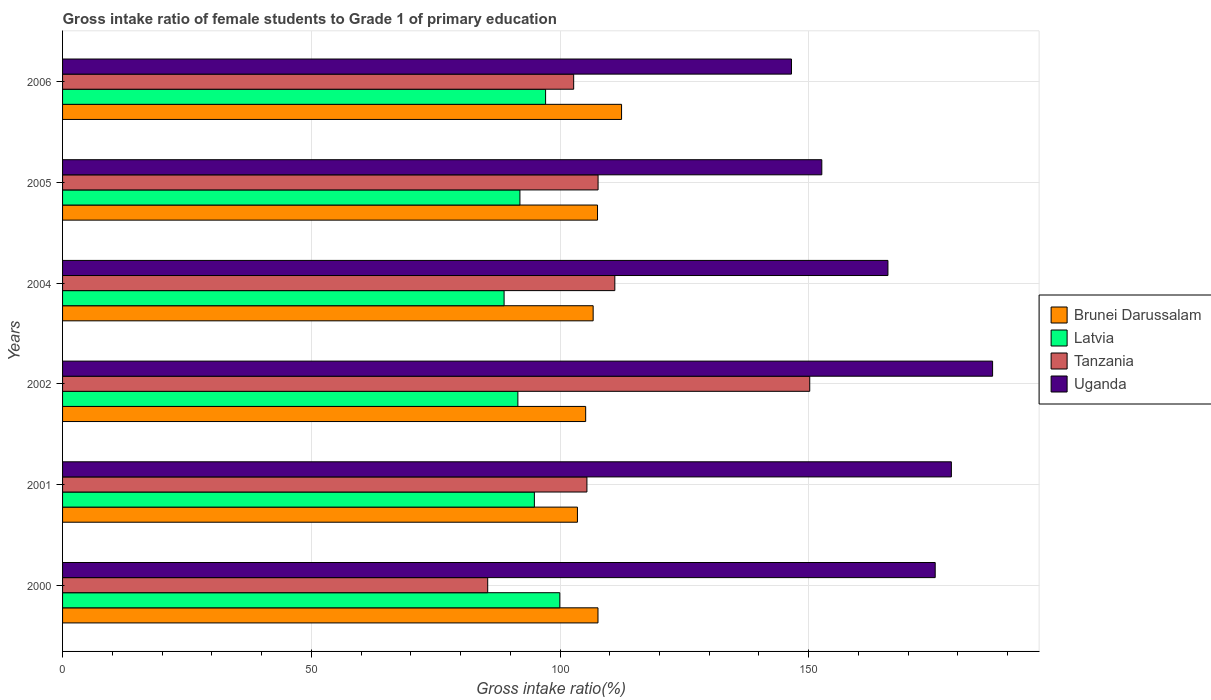How many different coloured bars are there?
Your answer should be compact. 4. Are the number of bars per tick equal to the number of legend labels?
Provide a short and direct response. Yes. Are the number of bars on each tick of the Y-axis equal?
Provide a succinct answer. Yes. How many bars are there on the 2nd tick from the top?
Offer a terse response. 4. How many bars are there on the 2nd tick from the bottom?
Keep it short and to the point. 4. In how many cases, is the number of bars for a given year not equal to the number of legend labels?
Provide a short and direct response. 0. What is the gross intake ratio in Tanzania in 2005?
Offer a very short reply. 107.65. Across all years, what is the maximum gross intake ratio in Tanzania?
Provide a short and direct response. 150.2. Across all years, what is the minimum gross intake ratio in Tanzania?
Provide a succinct answer. 85.47. What is the total gross intake ratio in Brunei Darussalam in the graph?
Your answer should be compact. 642.88. What is the difference between the gross intake ratio in Latvia in 2000 and that in 2006?
Keep it short and to the point. 2.86. What is the difference between the gross intake ratio in Latvia in 2004 and the gross intake ratio in Tanzania in 2000?
Provide a succinct answer. 3.29. What is the average gross intake ratio in Tanzania per year?
Give a very brief answer. 110.42. In the year 2004, what is the difference between the gross intake ratio in Tanzania and gross intake ratio in Latvia?
Offer a terse response. 22.26. In how many years, is the gross intake ratio in Latvia greater than 160 %?
Ensure brevity in your answer.  0. What is the ratio of the gross intake ratio in Uganda in 2000 to that in 2004?
Ensure brevity in your answer.  1.06. What is the difference between the highest and the second highest gross intake ratio in Latvia?
Your answer should be compact. 2.86. What is the difference between the highest and the lowest gross intake ratio in Uganda?
Provide a short and direct response. 40.43. In how many years, is the gross intake ratio in Latvia greater than the average gross intake ratio in Latvia taken over all years?
Provide a succinct answer. 3. Is the sum of the gross intake ratio in Latvia in 2002 and 2005 greater than the maximum gross intake ratio in Uganda across all years?
Offer a terse response. No. Is it the case that in every year, the sum of the gross intake ratio in Uganda and gross intake ratio in Tanzania is greater than the sum of gross intake ratio in Brunei Darussalam and gross intake ratio in Latvia?
Your response must be concise. Yes. What does the 2nd bar from the top in 2000 represents?
Offer a terse response. Tanzania. What does the 3rd bar from the bottom in 2001 represents?
Give a very brief answer. Tanzania. Is it the case that in every year, the sum of the gross intake ratio in Latvia and gross intake ratio in Uganda is greater than the gross intake ratio in Brunei Darussalam?
Your answer should be compact. Yes. Are all the bars in the graph horizontal?
Keep it short and to the point. Yes. How many years are there in the graph?
Your answer should be very brief. 6. How many legend labels are there?
Keep it short and to the point. 4. What is the title of the graph?
Your answer should be very brief. Gross intake ratio of female students to Grade 1 of primary education. Does "Channel Islands" appear as one of the legend labels in the graph?
Offer a very short reply. No. What is the label or title of the X-axis?
Keep it short and to the point. Gross intake ratio(%). What is the Gross intake ratio(%) in Brunei Darussalam in 2000?
Your answer should be compact. 107.64. What is the Gross intake ratio(%) in Latvia in 2000?
Your response must be concise. 99.96. What is the Gross intake ratio(%) in Tanzania in 2000?
Provide a succinct answer. 85.47. What is the Gross intake ratio(%) in Uganda in 2000?
Ensure brevity in your answer.  175.42. What is the Gross intake ratio(%) of Brunei Darussalam in 2001?
Keep it short and to the point. 103.5. What is the Gross intake ratio(%) of Latvia in 2001?
Provide a succinct answer. 94.85. What is the Gross intake ratio(%) in Tanzania in 2001?
Your answer should be very brief. 105.41. What is the Gross intake ratio(%) in Uganda in 2001?
Keep it short and to the point. 178.67. What is the Gross intake ratio(%) in Brunei Darussalam in 2002?
Give a very brief answer. 105.16. What is the Gross intake ratio(%) in Latvia in 2002?
Offer a very short reply. 91.53. What is the Gross intake ratio(%) in Tanzania in 2002?
Keep it short and to the point. 150.2. What is the Gross intake ratio(%) of Uganda in 2002?
Offer a terse response. 186.96. What is the Gross intake ratio(%) in Brunei Darussalam in 2004?
Keep it short and to the point. 106.66. What is the Gross intake ratio(%) of Latvia in 2004?
Offer a terse response. 88.76. What is the Gross intake ratio(%) of Tanzania in 2004?
Make the answer very short. 111.02. What is the Gross intake ratio(%) in Uganda in 2004?
Your response must be concise. 165.92. What is the Gross intake ratio(%) in Brunei Darussalam in 2005?
Your response must be concise. 107.54. What is the Gross intake ratio(%) of Latvia in 2005?
Offer a very short reply. 91.94. What is the Gross intake ratio(%) in Tanzania in 2005?
Your answer should be very brief. 107.65. What is the Gross intake ratio(%) in Uganda in 2005?
Offer a very short reply. 152.63. What is the Gross intake ratio(%) in Brunei Darussalam in 2006?
Give a very brief answer. 112.37. What is the Gross intake ratio(%) of Latvia in 2006?
Give a very brief answer. 97.1. What is the Gross intake ratio(%) of Tanzania in 2006?
Your response must be concise. 102.75. What is the Gross intake ratio(%) of Uganda in 2006?
Your answer should be very brief. 146.53. Across all years, what is the maximum Gross intake ratio(%) of Brunei Darussalam?
Offer a terse response. 112.37. Across all years, what is the maximum Gross intake ratio(%) of Latvia?
Provide a short and direct response. 99.96. Across all years, what is the maximum Gross intake ratio(%) of Tanzania?
Provide a short and direct response. 150.2. Across all years, what is the maximum Gross intake ratio(%) of Uganda?
Your response must be concise. 186.96. Across all years, what is the minimum Gross intake ratio(%) of Brunei Darussalam?
Make the answer very short. 103.5. Across all years, what is the minimum Gross intake ratio(%) in Latvia?
Keep it short and to the point. 88.76. Across all years, what is the minimum Gross intake ratio(%) of Tanzania?
Provide a succinct answer. 85.47. Across all years, what is the minimum Gross intake ratio(%) in Uganda?
Make the answer very short. 146.53. What is the total Gross intake ratio(%) in Brunei Darussalam in the graph?
Ensure brevity in your answer.  642.88. What is the total Gross intake ratio(%) in Latvia in the graph?
Your response must be concise. 564.14. What is the total Gross intake ratio(%) of Tanzania in the graph?
Offer a very short reply. 662.5. What is the total Gross intake ratio(%) of Uganda in the graph?
Provide a succinct answer. 1006.15. What is the difference between the Gross intake ratio(%) in Brunei Darussalam in 2000 and that in 2001?
Offer a terse response. 4.13. What is the difference between the Gross intake ratio(%) in Latvia in 2000 and that in 2001?
Give a very brief answer. 5.11. What is the difference between the Gross intake ratio(%) in Tanzania in 2000 and that in 2001?
Give a very brief answer. -19.95. What is the difference between the Gross intake ratio(%) in Uganda in 2000 and that in 2001?
Your answer should be very brief. -3.25. What is the difference between the Gross intake ratio(%) in Brunei Darussalam in 2000 and that in 2002?
Your answer should be compact. 2.48. What is the difference between the Gross intake ratio(%) in Latvia in 2000 and that in 2002?
Your answer should be compact. 8.43. What is the difference between the Gross intake ratio(%) of Tanzania in 2000 and that in 2002?
Provide a succinct answer. -64.74. What is the difference between the Gross intake ratio(%) of Uganda in 2000 and that in 2002?
Make the answer very short. -11.54. What is the difference between the Gross intake ratio(%) in Brunei Darussalam in 2000 and that in 2004?
Provide a short and direct response. 0.97. What is the difference between the Gross intake ratio(%) of Latvia in 2000 and that in 2004?
Offer a very short reply. 11.2. What is the difference between the Gross intake ratio(%) of Tanzania in 2000 and that in 2004?
Ensure brevity in your answer.  -25.55. What is the difference between the Gross intake ratio(%) of Uganda in 2000 and that in 2004?
Provide a succinct answer. 9.5. What is the difference between the Gross intake ratio(%) of Brunei Darussalam in 2000 and that in 2005?
Keep it short and to the point. 0.09. What is the difference between the Gross intake ratio(%) in Latvia in 2000 and that in 2005?
Give a very brief answer. 8.02. What is the difference between the Gross intake ratio(%) of Tanzania in 2000 and that in 2005?
Your response must be concise. -22.19. What is the difference between the Gross intake ratio(%) of Uganda in 2000 and that in 2005?
Ensure brevity in your answer.  22.8. What is the difference between the Gross intake ratio(%) in Brunei Darussalam in 2000 and that in 2006?
Give a very brief answer. -4.74. What is the difference between the Gross intake ratio(%) in Latvia in 2000 and that in 2006?
Keep it short and to the point. 2.86. What is the difference between the Gross intake ratio(%) of Tanzania in 2000 and that in 2006?
Ensure brevity in your answer.  -17.28. What is the difference between the Gross intake ratio(%) of Uganda in 2000 and that in 2006?
Provide a succinct answer. 28.89. What is the difference between the Gross intake ratio(%) of Brunei Darussalam in 2001 and that in 2002?
Ensure brevity in your answer.  -1.65. What is the difference between the Gross intake ratio(%) in Latvia in 2001 and that in 2002?
Your answer should be very brief. 3.32. What is the difference between the Gross intake ratio(%) of Tanzania in 2001 and that in 2002?
Your answer should be compact. -44.79. What is the difference between the Gross intake ratio(%) in Uganda in 2001 and that in 2002?
Make the answer very short. -8.29. What is the difference between the Gross intake ratio(%) of Brunei Darussalam in 2001 and that in 2004?
Offer a very short reply. -3.16. What is the difference between the Gross intake ratio(%) in Latvia in 2001 and that in 2004?
Offer a terse response. 6.09. What is the difference between the Gross intake ratio(%) of Tanzania in 2001 and that in 2004?
Keep it short and to the point. -5.61. What is the difference between the Gross intake ratio(%) of Uganda in 2001 and that in 2004?
Provide a succinct answer. 12.75. What is the difference between the Gross intake ratio(%) in Brunei Darussalam in 2001 and that in 2005?
Offer a terse response. -4.04. What is the difference between the Gross intake ratio(%) of Latvia in 2001 and that in 2005?
Your response must be concise. 2.9. What is the difference between the Gross intake ratio(%) of Tanzania in 2001 and that in 2005?
Keep it short and to the point. -2.24. What is the difference between the Gross intake ratio(%) in Uganda in 2001 and that in 2005?
Your answer should be compact. 26.05. What is the difference between the Gross intake ratio(%) of Brunei Darussalam in 2001 and that in 2006?
Keep it short and to the point. -8.87. What is the difference between the Gross intake ratio(%) of Latvia in 2001 and that in 2006?
Ensure brevity in your answer.  -2.26. What is the difference between the Gross intake ratio(%) in Tanzania in 2001 and that in 2006?
Provide a succinct answer. 2.66. What is the difference between the Gross intake ratio(%) of Uganda in 2001 and that in 2006?
Offer a very short reply. 32.14. What is the difference between the Gross intake ratio(%) in Brunei Darussalam in 2002 and that in 2004?
Your response must be concise. -1.51. What is the difference between the Gross intake ratio(%) of Latvia in 2002 and that in 2004?
Your answer should be compact. 2.77. What is the difference between the Gross intake ratio(%) in Tanzania in 2002 and that in 2004?
Keep it short and to the point. 39.18. What is the difference between the Gross intake ratio(%) in Uganda in 2002 and that in 2004?
Give a very brief answer. 21.04. What is the difference between the Gross intake ratio(%) in Brunei Darussalam in 2002 and that in 2005?
Provide a succinct answer. -2.38. What is the difference between the Gross intake ratio(%) in Latvia in 2002 and that in 2005?
Give a very brief answer. -0.41. What is the difference between the Gross intake ratio(%) in Tanzania in 2002 and that in 2005?
Give a very brief answer. 42.55. What is the difference between the Gross intake ratio(%) of Uganda in 2002 and that in 2005?
Ensure brevity in your answer.  34.33. What is the difference between the Gross intake ratio(%) in Brunei Darussalam in 2002 and that in 2006?
Your response must be concise. -7.21. What is the difference between the Gross intake ratio(%) in Latvia in 2002 and that in 2006?
Offer a very short reply. -5.57. What is the difference between the Gross intake ratio(%) in Tanzania in 2002 and that in 2006?
Provide a succinct answer. 47.45. What is the difference between the Gross intake ratio(%) in Uganda in 2002 and that in 2006?
Give a very brief answer. 40.43. What is the difference between the Gross intake ratio(%) in Brunei Darussalam in 2004 and that in 2005?
Provide a succinct answer. -0.88. What is the difference between the Gross intake ratio(%) in Latvia in 2004 and that in 2005?
Your answer should be compact. -3.18. What is the difference between the Gross intake ratio(%) of Tanzania in 2004 and that in 2005?
Ensure brevity in your answer.  3.37. What is the difference between the Gross intake ratio(%) of Uganda in 2004 and that in 2005?
Your response must be concise. 13.29. What is the difference between the Gross intake ratio(%) of Brunei Darussalam in 2004 and that in 2006?
Provide a succinct answer. -5.71. What is the difference between the Gross intake ratio(%) of Latvia in 2004 and that in 2006?
Provide a succinct answer. -8.34. What is the difference between the Gross intake ratio(%) in Tanzania in 2004 and that in 2006?
Provide a succinct answer. 8.27. What is the difference between the Gross intake ratio(%) of Uganda in 2004 and that in 2006?
Offer a very short reply. 19.39. What is the difference between the Gross intake ratio(%) of Brunei Darussalam in 2005 and that in 2006?
Offer a very short reply. -4.83. What is the difference between the Gross intake ratio(%) of Latvia in 2005 and that in 2006?
Provide a succinct answer. -5.16. What is the difference between the Gross intake ratio(%) in Tanzania in 2005 and that in 2006?
Your answer should be very brief. 4.91. What is the difference between the Gross intake ratio(%) in Uganda in 2005 and that in 2006?
Ensure brevity in your answer.  6.09. What is the difference between the Gross intake ratio(%) of Brunei Darussalam in 2000 and the Gross intake ratio(%) of Latvia in 2001?
Offer a very short reply. 12.79. What is the difference between the Gross intake ratio(%) in Brunei Darussalam in 2000 and the Gross intake ratio(%) in Tanzania in 2001?
Make the answer very short. 2.22. What is the difference between the Gross intake ratio(%) in Brunei Darussalam in 2000 and the Gross intake ratio(%) in Uganda in 2001?
Keep it short and to the point. -71.04. What is the difference between the Gross intake ratio(%) of Latvia in 2000 and the Gross intake ratio(%) of Tanzania in 2001?
Make the answer very short. -5.45. What is the difference between the Gross intake ratio(%) of Latvia in 2000 and the Gross intake ratio(%) of Uganda in 2001?
Provide a short and direct response. -78.71. What is the difference between the Gross intake ratio(%) of Tanzania in 2000 and the Gross intake ratio(%) of Uganda in 2001?
Offer a very short reply. -93.21. What is the difference between the Gross intake ratio(%) of Brunei Darussalam in 2000 and the Gross intake ratio(%) of Latvia in 2002?
Provide a succinct answer. 16.1. What is the difference between the Gross intake ratio(%) in Brunei Darussalam in 2000 and the Gross intake ratio(%) in Tanzania in 2002?
Your answer should be compact. -42.57. What is the difference between the Gross intake ratio(%) in Brunei Darussalam in 2000 and the Gross intake ratio(%) in Uganda in 2002?
Give a very brief answer. -79.33. What is the difference between the Gross intake ratio(%) in Latvia in 2000 and the Gross intake ratio(%) in Tanzania in 2002?
Give a very brief answer. -50.24. What is the difference between the Gross intake ratio(%) of Latvia in 2000 and the Gross intake ratio(%) of Uganda in 2002?
Keep it short and to the point. -87. What is the difference between the Gross intake ratio(%) in Tanzania in 2000 and the Gross intake ratio(%) in Uganda in 2002?
Ensure brevity in your answer.  -101.5. What is the difference between the Gross intake ratio(%) of Brunei Darussalam in 2000 and the Gross intake ratio(%) of Latvia in 2004?
Make the answer very short. 18.88. What is the difference between the Gross intake ratio(%) in Brunei Darussalam in 2000 and the Gross intake ratio(%) in Tanzania in 2004?
Your response must be concise. -3.38. What is the difference between the Gross intake ratio(%) in Brunei Darussalam in 2000 and the Gross intake ratio(%) in Uganda in 2004?
Make the answer very short. -58.29. What is the difference between the Gross intake ratio(%) of Latvia in 2000 and the Gross intake ratio(%) of Tanzania in 2004?
Make the answer very short. -11.06. What is the difference between the Gross intake ratio(%) of Latvia in 2000 and the Gross intake ratio(%) of Uganda in 2004?
Offer a very short reply. -65.96. What is the difference between the Gross intake ratio(%) in Tanzania in 2000 and the Gross intake ratio(%) in Uganda in 2004?
Provide a succinct answer. -80.46. What is the difference between the Gross intake ratio(%) in Brunei Darussalam in 2000 and the Gross intake ratio(%) in Latvia in 2005?
Keep it short and to the point. 15.69. What is the difference between the Gross intake ratio(%) of Brunei Darussalam in 2000 and the Gross intake ratio(%) of Tanzania in 2005?
Ensure brevity in your answer.  -0.02. What is the difference between the Gross intake ratio(%) of Brunei Darussalam in 2000 and the Gross intake ratio(%) of Uganda in 2005?
Your answer should be compact. -44.99. What is the difference between the Gross intake ratio(%) of Latvia in 2000 and the Gross intake ratio(%) of Tanzania in 2005?
Offer a very short reply. -7.69. What is the difference between the Gross intake ratio(%) of Latvia in 2000 and the Gross intake ratio(%) of Uganda in 2005?
Keep it short and to the point. -52.67. What is the difference between the Gross intake ratio(%) in Tanzania in 2000 and the Gross intake ratio(%) in Uganda in 2005?
Provide a short and direct response. -67.16. What is the difference between the Gross intake ratio(%) of Brunei Darussalam in 2000 and the Gross intake ratio(%) of Latvia in 2006?
Your answer should be compact. 10.53. What is the difference between the Gross intake ratio(%) of Brunei Darussalam in 2000 and the Gross intake ratio(%) of Tanzania in 2006?
Make the answer very short. 4.89. What is the difference between the Gross intake ratio(%) in Brunei Darussalam in 2000 and the Gross intake ratio(%) in Uganda in 2006?
Offer a very short reply. -38.9. What is the difference between the Gross intake ratio(%) in Latvia in 2000 and the Gross intake ratio(%) in Tanzania in 2006?
Ensure brevity in your answer.  -2.79. What is the difference between the Gross intake ratio(%) of Latvia in 2000 and the Gross intake ratio(%) of Uganda in 2006?
Provide a succinct answer. -46.57. What is the difference between the Gross intake ratio(%) in Tanzania in 2000 and the Gross intake ratio(%) in Uganda in 2006?
Keep it short and to the point. -61.07. What is the difference between the Gross intake ratio(%) in Brunei Darussalam in 2001 and the Gross intake ratio(%) in Latvia in 2002?
Offer a very short reply. 11.97. What is the difference between the Gross intake ratio(%) in Brunei Darussalam in 2001 and the Gross intake ratio(%) in Tanzania in 2002?
Offer a very short reply. -46.7. What is the difference between the Gross intake ratio(%) of Brunei Darussalam in 2001 and the Gross intake ratio(%) of Uganda in 2002?
Offer a terse response. -83.46. What is the difference between the Gross intake ratio(%) in Latvia in 2001 and the Gross intake ratio(%) in Tanzania in 2002?
Give a very brief answer. -55.36. What is the difference between the Gross intake ratio(%) of Latvia in 2001 and the Gross intake ratio(%) of Uganda in 2002?
Offer a terse response. -92.12. What is the difference between the Gross intake ratio(%) in Tanzania in 2001 and the Gross intake ratio(%) in Uganda in 2002?
Make the answer very short. -81.55. What is the difference between the Gross intake ratio(%) in Brunei Darussalam in 2001 and the Gross intake ratio(%) in Latvia in 2004?
Your answer should be compact. 14.74. What is the difference between the Gross intake ratio(%) in Brunei Darussalam in 2001 and the Gross intake ratio(%) in Tanzania in 2004?
Your answer should be very brief. -7.52. What is the difference between the Gross intake ratio(%) of Brunei Darussalam in 2001 and the Gross intake ratio(%) of Uganda in 2004?
Offer a terse response. -62.42. What is the difference between the Gross intake ratio(%) of Latvia in 2001 and the Gross intake ratio(%) of Tanzania in 2004?
Provide a succinct answer. -16.17. What is the difference between the Gross intake ratio(%) of Latvia in 2001 and the Gross intake ratio(%) of Uganda in 2004?
Your response must be concise. -71.08. What is the difference between the Gross intake ratio(%) in Tanzania in 2001 and the Gross intake ratio(%) in Uganda in 2004?
Make the answer very short. -60.51. What is the difference between the Gross intake ratio(%) of Brunei Darussalam in 2001 and the Gross intake ratio(%) of Latvia in 2005?
Your answer should be compact. 11.56. What is the difference between the Gross intake ratio(%) in Brunei Darussalam in 2001 and the Gross intake ratio(%) in Tanzania in 2005?
Provide a succinct answer. -4.15. What is the difference between the Gross intake ratio(%) of Brunei Darussalam in 2001 and the Gross intake ratio(%) of Uganda in 2005?
Make the answer very short. -49.12. What is the difference between the Gross intake ratio(%) of Latvia in 2001 and the Gross intake ratio(%) of Tanzania in 2005?
Your response must be concise. -12.81. What is the difference between the Gross intake ratio(%) of Latvia in 2001 and the Gross intake ratio(%) of Uganda in 2005?
Offer a terse response. -57.78. What is the difference between the Gross intake ratio(%) of Tanzania in 2001 and the Gross intake ratio(%) of Uganda in 2005?
Your answer should be compact. -47.22. What is the difference between the Gross intake ratio(%) of Brunei Darussalam in 2001 and the Gross intake ratio(%) of Latvia in 2006?
Your answer should be very brief. 6.4. What is the difference between the Gross intake ratio(%) of Brunei Darussalam in 2001 and the Gross intake ratio(%) of Tanzania in 2006?
Your response must be concise. 0.76. What is the difference between the Gross intake ratio(%) of Brunei Darussalam in 2001 and the Gross intake ratio(%) of Uganda in 2006?
Ensure brevity in your answer.  -43.03. What is the difference between the Gross intake ratio(%) of Latvia in 2001 and the Gross intake ratio(%) of Tanzania in 2006?
Provide a succinct answer. -7.9. What is the difference between the Gross intake ratio(%) of Latvia in 2001 and the Gross intake ratio(%) of Uganda in 2006?
Offer a very short reply. -51.69. What is the difference between the Gross intake ratio(%) in Tanzania in 2001 and the Gross intake ratio(%) in Uganda in 2006?
Your answer should be very brief. -41.12. What is the difference between the Gross intake ratio(%) in Brunei Darussalam in 2002 and the Gross intake ratio(%) in Latvia in 2004?
Give a very brief answer. 16.4. What is the difference between the Gross intake ratio(%) of Brunei Darussalam in 2002 and the Gross intake ratio(%) of Tanzania in 2004?
Offer a terse response. -5.86. What is the difference between the Gross intake ratio(%) of Brunei Darussalam in 2002 and the Gross intake ratio(%) of Uganda in 2004?
Offer a very short reply. -60.76. What is the difference between the Gross intake ratio(%) of Latvia in 2002 and the Gross intake ratio(%) of Tanzania in 2004?
Your response must be concise. -19.49. What is the difference between the Gross intake ratio(%) of Latvia in 2002 and the Gross intake ratio(%) of Uganda in 2004?
Your answer should be compact. -74.39. What is the difference between the Gross intake ratio(%) in Tanzania in 2002 and the Gross intake ratio(%) in Uganda in 2004?
Your answer should be very brief. -15.72. What is the difference between the Gross intake ratio(%) of Brunei Darussalam in 2002 and the Gross intake ratio(%) of Latvia in 2005?
Make the answer very short. 13.22. What is the difference between the Gross intake ratio(%) in Brunei Darussalam in 2002 and the Gross intake ratio(%) in Tanzania in 2005?
Provide a succinct answer. -2.49. What is the difference between the Gross intake ratio(%) in Brunei Darussalam in 2002 and the Gross intake ratio(%) in Uganda in 2005?
Offer a terse response. -47.47. What is the difference between the Gross intake ratio(%) of Latvia in 2002 and the Gross intake ratio(%) of Tanzania in 2005?
Provide a succinct answer. -16.12. What is the difference between the Gross intake ratio(%) in Latvia in 2002 and the Gross intake ratio(%) in Uganda in 2005?
Ensure brevity in your answer.  -61.1. What is the difference between the Gross intake ratio(%) in Tanzania in 2002 and the Gross intake ratio(%) in Uganda in 2005?
Keep it short and to the point. -2.43. What is the difference between the Gross intake ratio(%) in Brunei Darussalam in 2002 and the Gross intake ratio(%) in Latvia in 2006?
Your response must be concise. 8.06. What is the difference between the Gross intake ratio(%) in Brunei Darussalam in 2002 and the Gross intake ratio(%) in Tanzania in 2006?
Your answer should be compact. 2.41. What is the difference between the Gross intake ratio(%) in Brunei Darussalam in 2002 and the Gross intake ratio(%) in Uganda in 2006?
Offer a terse response. -41.38. What is the difference between the Gross intake ratio(%) in Latvia in 2002 and the Gross intake ratio(%) in Tanzania in 2006?
Your response must be concise. -11.22. What is the difference between the Gross intake ratio(%) of Latvia in 2002 and the Gross intake ratio(%) of Uganda in 2006?
Provide a short and direct response. -55. What is the difference between the Gross intake ratio(%) of Tanzania in 2002 and the Gross intake ratio(%) of Uganda in 2006?
Give a very brief answer. 3.67. What is the difference between the Gross intake ratio(%) in Brunei Darussalam in 2004 and the Gross intake ratio(%) in Latvia in 2005?
Ensure brevity in your answer.  14.72. What is the difference between the Gross intake ratio(%) in Brunei Darussalam in 2004 and the Gross intake ratio(%) in Tanzania in 2005?
Give a very brief answer. -0.99. What is the difference between the Gross intake ratio(%) in Brunei Darussalam in 2004 and the Gross intake ratio(%) in Uganda in 2005?
Make the answer very short. -45.96. What is the difference between the Gross intake ratio(%) of Latvia in 2004 and the Gross intake ratio(%) of Tanzania in 2005?
Offer a terse response. -18.89. What is the difference between the Gross intake ratio(%) in Latvia in 2004 and the Gross intake ratio(%) in Uganda in 2005?
Offer a terse response. -63.87. What is the difference between the Gross intake ratio(%) in Tanzania in 2004 and the Gross intake ratio(%) in Uganda in 2005?
Provide a succinct answer. -41.61. What is the difference between the Gross intake ratio(%) in Brunei Darussalam in 2004 and the Gross intake ratio(%) in Latvia in 2006?
Ensure brevity in your answer.  9.56. What is the difference between the Gross intake ratio(%) of Brunei Darussalam in 2004 and the Gross intake ratio(%) of Tanzania in 2006?
Make the answer very short. 3.92. What is the difference between the Gross intake ratio(%) of Brunei Darussalam in 2004 and the Gross intake ratio(%) of Uganda in 2006?
Your answer should be compact. -39.87. What is the difference between the Gross intake ratio(%) in Latvia in 2004 and the Gross intake ratio(%) in Tanzania in 2006?
Give a very brief answer. -13.99. What is the difference between the Gross intake ratio(%) of Latvia in 2004 and the Gross intake ratio(%) of Uganda in 2006?
Ensure brevity in your answer.  -57.77. What is the difference between the Gross intake ratio(%) in Tanzania in 2004 and the Gross intake ratio(%) in Uganda in 2006?
Make the answer very short. -35.51. What is the difference between the Gross intake ratio(%) in Brunei Darussalam in 2005 and the Gross intake ratio(%) in Latvia in 2006?
Make the answer very short. 10.44. What is the difference between the Gross intake ratio(%) in Brunei Darussalam in 2005 and the Gross intake ratio(%) in Tanzania in 2006?
Provide a succinct answer. 4.79. What is the difference between the Gross intake ratio(%) in Brunei Darussalam in 2005 and the Gross intake ratio(%) in Uganda in 2006?
Your answer should be very brief. -38.99. What is the difference between the Gross intake ratio(%) in Latvia in 2005 and the Gross intake ratio(%) in Tanzania in 2006?
Provide a succinct answer. -10.81. What is the difference between the Gross intake ratio(%) in Latvia in 2005 and the Gross intake ratio(%) in Uganda in 2006?
Make the answer very short. -54.59. What is the difference between the Gross intake ratio(%) in Tanzania in 2005 and the Gross intake ratio(%) in Uganda in 2006?
Keep it short and to the point. -38.88. What is the average Gross intake ratio(%) in Brunei Darussalam per year?
Provide a succinct answer. 107.15. What is the average Gross intake ratio(%) in Latvia per year?
Your answer should be compact. 94.02. What is the average Gross intake ratio(%) of Tanzania per year?
Your answer should be compact. 110.42. What is the average Gross intake ratio(%) of Uganda per year?
Your response must be concise. 167.69. In the year 2000, what is the difference between the Gross intake ratio(%) in Brunei Darussalam and Gross intake ratio(%) in Latvia?
Provide a short and direct response. 7.68. In the year 2000, what is the difference between the Gross intake ratio(%) of Brunei Darussalam and Gross intake ratio(%) of Tanzania?
Your answer should be very brief. 22.17. In the year 2000, what is the difference between the Gross intake ratio(%) in Brunei Darussalam and Gross intake ratio(%) in Uganda?
Your answer should be compact. -67.79. In the year 2000, what is the difference between the Gross intake ratio(%) in Latvia and Gross intake ratio(%) in Tanzania?
Offer a very short reply. 14.49. In the year 2000, what is the difference between the Gross intake ratio(%) of Latvia and Gross intake ratio(%) of Uganda?
Offer a very short reply. -75.46. In the year 2000, what is the difference between the Gross intake ratio(%) in Tanzania and Gross intake ratio(%) in Uganda?
Keep it short and to the point. -89.96. In the year 2001, what is the difference between the Gross intake ratio(%) of Brunei Darussalam and Gross intake ratio(%) of Latvia?
Offer a terse response. 8.66. In the year 2001, what is the difference between the Gross intake ratio(%) of Brunei Darussalam and Gross intake ratio(%) of Tanzania?
Ensure brevity in your answer.  -1.91. In the year 2001, what is the difference between the Gross intake ratio(%) of Brunei Darussalam and Gross intake ratio(%) of Uganda?
Offer a very short reply. -75.17. In the year 2001, what is the difference between the Gross intake ratio(%) in Latvia and Gross intake ratio(%) in Tanzania?
Keep it short and to the point. -10.56. In the year 2001, what is the difference between the Gross intake ratio(%) of Latvia and Gross intake ratio(%) of Uganda?
Give a very brief answer. -83.83. In the year 2001, what is the difference between the Gross intake ratio(%) in Tanzania and Gross intake ratio(%) in Uganda?
Keep it short and to the point. -73.26. In the year 2002, what is the difference between the Gross intake ratio(%) of Brunei Darussalam and Gross intake ratio(%) of Latvia?
Provide a succinct answer. 13.63. In the year 2002, what is the difference between the Gross intake ratio(%) of Brunei Darussalam and Gross intake ratio(%) of Tanzania?
Your answer should be very brief. -45.04. In the year 2002, what is the difference between the Gross intake ratio(%) of Brunei Darussalam and Gross intake ratio(%) of Uganda?
Offer a very short reply. -81.8. In the year 2002, what is the difference between the Gross intake ratio(%) in Latvia and Gross intake ratio(%) in Tanzania?
Ensure brevity in your answer.  -58.67. In the year 2002, what is the difference between the Gross intake ratio(%) of Latvia and Gross intake ratio(%) of Uganda?
Provide a succinct answer. -95.43. In the year 2002, what is the difference between the Gross intake ratio(%) in Tanzania and Gross intake ratio(%) in Uganda?
Your answer should be compact. -36.76. In the year 2004, what is the difference between the Gross intake ratio(%) of Brunei Darussalam and Gross intake ratio(%) of Latvia?
Your answer should be compact. 17.9. In the year 2004, what is the difference between the Gross intake ratio(%) of Brunei Darussalam and Gross intake ratio(%) of Tanzania?
Give a very brief answer. -4.36. In the year 2004, what is the difference between the Gross intake ratio(%) of Brunei Darussalam and Gross intake ratio(%) of Uganda?
Keep it short and to the point. -59.26. In the year 2004, what is the difference between the Gross intake ratio(%) of Latvia and Gross intake ratio(%) of Tanzania?
Provide a short and direct response. -22.26. In the year 2004, what is the difference between the Gross intake ratio(%) in Latvia and Gross intake ratio(%) in Uganda?
Keep it short and to the point. -77.16. In the year 2004, what is the difference between the Gross intake ratio(%) of Tanzania and Gross intake ratio(%) of Uganda?
Offer a very short reply. -54.9. In the year 2005, what is the difference between the Gross intake ratio(%) in Brunei Darussalam and Gross intake ratio(%) in Latvia?
Your answer should be compact. 15.6. In the year 2005, what is the difference between the Gross intake ratio(%) in Brunei Darussalam and Gross intake ratio(%) in Tanzania?
Make the answer very short. -0.11. In the year 2005, what is the difference between the Gross intake ratio(%) of Brunei Darussalam and Gross intake ratio(%) of Uganda?
Keep it short and to the point. -45.09. In the year 2005, what is the difference between the Gross intake ratio(%) in Latvia and Gross intake ratio(%) in Tanzania?
Your answer should be compact. -15.71. In the year 2005, what is the difference between the Gross intake ratio(%) of Latvia and Gross intake ratio(%) of Uganda?
Ensure brevity in your answer.  -60.69. In the year 2005, what is the difference between the Gross intake ratio(%) of Tanzania and Gross intake ratio(%) of Uganda?
Ensure brevity in your answer.  -44.98. In the year 2006, what is the difference between the Gross intake ratio(%) of Brunei Darussalam and Gross intake ratio(%) of Latvia?
Your answer should be very brief. 15.27. In the year 2006, what is the difference between the Gross intake ratio(%) in Brunei Darussalam and Gross intake ratio(%) in Tanzania?
Offer a terse response. 9.63. In the year 2006, what is the difference between the Gross intake ratio(%) of Brunei Darussalam and Gross intake ratio(%) of Uganda?
Offer a terse response. -34.16. In the year 2006, what is the difference between the Gross intake ratio(%) in Latvia and Gross intake ratio(%) in Tanzania?
Your answer should be very brief. -5.64. In the year 2006, what is the difference between the Gross intake ratio(%) of Latvia and Gross intake ratio(%) of Uganda?
Your answer should be very brief. -49.43. In the year 2006, what is the difference between the Gross intake ratio(%) in Tanzania and Gross intake ratio(%) in Uganda?
Your answer should be very brief. -43.79. What is the ratio of the Gross intake ratio(%) of Brunei Darussalam in 2000 to that in 2001?
Your answer should be very brief. 1.04. What is the ratio of the Gross intake ratio(%) in Latvia in 2000 to that in 2001?
Provide a short and direct response. 1.05. What is the ratio of the Gross intake ratio(%) in Tanzania in 2000 to that in 2001?
Your answer should be very brief. 0.81. What is the ratio of the Gross intake ratio(%) in Uganda in 2000 to that in 2001?
Offer a terse response. 0.98. What is the ratio of the Gross intake ratio(%) in Brunei Darussalam in 2000 to that in 2002?
Provide a short and direct response. 1.02. What is the ratio of the Gross intake ratio(%) of Latvia in 2000 to that in 2002?
Ensure brevity in your answer.  1.09. What is the ratio of the Gross intake ratio(%) in Tanzania in 2000 to that in 2002?
Your answer should be compact. 0.57. What is the ratio of the Gross intake ratio(%) in Uganda in 2000 to that in 2002?
Your response must be concise. 0.94. What is the ratio of the Gross intake ratio(%) of Brunei Darussalam in 2000 to that in 2004?
Offer a very short reply. 1.01. What is the ratio of the Gross intake ratio(%) in Latvia in 2000 to that in 2004?
Make the answer very short. 1.13. What is the ratio of the Gross intake ratio(%) in Tanzania in 2000 to that in 2004?
Keep it short and to the point. 0.77. What is the ratio of the Gross intake ratio(%) in Uganda in 2000 to that in 2004?
Your answer should be very brief. 1.06. What is the ratio of the Gross intake ratio(%) of Brunei Darussalam in 2000 to that in 2005?
Provide a succinct answer. 1. What is the ratio of the Gross intake ratio(%) of Latvia in 2000 to that in 2005?
Ensure brevity in your answer.  1.09. What is the ratio of the Gross intake ratio(%) in Tanzania in 2000 to that in 2005?
Offer a terse response. 0.79. What is the ratio of the Gross intake ratio(%) of Uganda in 2000 to that in 2005?
Provide a short and direct response. 1.15. What is the ratio of the Gross intake ratio(%) of Brunei Darussalam in 2000 to that in 2006?
Keep it short and to the point. 0.96. What is the ratio of the Gross intake ratio(%) of Latvia in 2000 to that in 2006?
Give a very brief answer. 1.03. What is the ratio of the Gross intake ratio(%) in Tanzania in 2000 to that in 2006?
Provide a succinct answer. 0.83. What is the ratio of the Gross intake ratio(%) in Uganda in 2000 to that in 2006?
Give a very brief answer. 1.2. What is the ratio of the Gross intake ratio(%) of Brunei Darussalam in 2001 to that in 2002?
Keep it short and to the point. 0.98. What is the ratio of the Gross intake ratio(%) of Latvia in 2001 to that in 2002?
Provide a short and direct response. 1.04. What is the ratio of the Gross intake ratio(%) in Tanzania in 2001 to that in 2002?
Make the answer very short. 0.7. What is the ratio of the Gross intake ratio(%) of Uganda in 2001 to that in 2002?
Keep it short and to the point. 0.96. What is the ratio of the Gross intake ratio(%) in Brunei Darussalam in 2001 to that in 2004?
Your answer should be compact. 0.97. What is the ratio of the Gross intake ratio(%) in Latvia in 2001 to that in 2004?
Offer a very short reply. 1.07. What is the ratio of the Gross intake ratio(%) in Tanzania in 2001 to that in 2004?
Keep it short and to the point. 0.95. What is the ratio of the Gross intake ratio(%) of Brunei Darussalam in 2001 to that in 2005?
Offer a very short reply. 0.96. What is the ratio of the Gross intake ratio(%) of Latvia in 2001 to that in 2005?
Your response must be concise. 1.03. What is the ratio of the Gross intake ratio(%) of Tanzania in 2001 to that in 2005?
Your answer should be compact. 0.98. What is the ratio of the Gross intake ratio(%) of Uganda in 2001 to that in 2005?
Your answer should be compact. 1.17. What is the ratio of the Gross intake ratio(%) of Brunei Darussalam in 2001 to that in 2006?
Ensure brevity in your answer.  0.92. What is the ratio of the Gross intake ratio(%) in Latvia in 2001 to that in 2006?
Keep it short and to the point. 0.98. What is the ratio of the Gross intake ratio(%) of Tanzania in 2001 to that in 2006?
Give a very brief answer. 1.03. What is the ratio of the Gross intake ratio(%) of Uganda in 2001 to that in 2006?
Provide a succinct answer. 1.22. What is the ratio of the Gross intake ratio(%) of Brunei Darussalam in 2002 to that in 2004?
Your answer should be very brief. 0.99. What is the ratio of the Gross intake ratio(%) of Latvia in 2002 to that in 2004?
Keep it short and to the point. 1.03. What is the ratio of the Gross intake ratio(%) of Tanzania in 2002 to that in 2004?
Provide a succinct answer. 1.35. What is the ratio of the Gross intake ratio(%) of Uganda in 2002 to that in 2004?
Keep it short and to the point. 1.13. What is the ratio of the Gross intake ratio(%) in Brunei Darussalam in 2002 to that in 2005?
Give a very brief answer. 0.98. What is the ratio of the Gross intake ratio(%) in Latvia in 2002 to that in 2005?
Make the answer very short. 1. What is the ratio of the Gross intake ratio(%) of Tanzania in 2002 to that in 2005?
Give a very brief answer. 1.4. What is the ratio of the Gross intake ratio(%) of Uganda in 2002 to that in 2005?
Your answer should be very brief. 1.23. What is the ratio of the Gross intake ratio(%) in Brunei Darussalam in 2002 to that in 2006?
Provide a succinct answer. 0.94. What is the ratio of the Gross intake ratio(%) of Latvia in 2002 to that in 2006?
Provide a short and direct response. 0.94. What is the ratio of the Gross intake ratio(%) in Tanzania in 2002 to that in 2006?
Offer a terse response. 1.46. What is the ratio of the Gross intake ratio(%) in Uganda in 2002 to that in 2006?
Give a very brief answer. 1.28. What is the ratio of the Gross intake ratio(%) of Latvia in 2004 to that in 2005?
Provide a succinct answer. 0.97. What is the ratio of the Gross intake ratio(%) of Tanzania in 2004 to that in 2005?
Give a very brief answer. 1.03. What is the ratio of the Gross intake ratio(%) in Uganda in 2004 to that in 2005?
Keep it short and to the point. 1.09. What is the ratio of the Gross intake ratio(%) in Brunei Darussalam in 2004 to that in 2006?
Offer a very short reply. 0.95. What is the ratio of the Gross intake ratio(%) of Latvia in 2004 to that in 2006?
Ensure brevity in your answer.  0.91. What is the ratio of the Gross intake ratio(%) in Tanzania in 2004 to that in 2006?
Your answer should be very brief. 1.08. What is the ratio of the Gross intake ratio(%) in Uganda in 2004 to that in 2006?
Make the answer very short. 1.13. What is the ratio of the Gross intake ratio(%) in Brunei Darussalam in 2005 to that in 2006?
Make the answer very short. 0.96. What is the ratio of the Gross intake ratio(%) in Latvia in 2005 to that in 2006?
Offer a very short reply. 0.95. What is the ratio of the Gross intake ratio(%) in Tanzania in 2005 to that in 2006?
Provide a succinct answer. 1.05. What is the ratio of the Gross intake ratio(%) of Uganda in 2005 to that in 2006?
Provide a short and direct response. 1.04. What is the difference between the highest and the second highest Gross intake ratio(%) of Brunei Darussalam?
Your response must be concise. 4.74. What is the difference between the highest and the second highest Gross intake ratio(%) of Latvia?
Ensure brevity in your answer.  2.86. What is the difference between the highest and the second highest Gross intake ratio(%) in Tanzania?
Give a very brief answer. 39.18. What is the difference between the highest and the second highest Gross intake ratio(%) of Uganda?
Ensure brevity in your answer.  8.29. What is the difference between the highest and the lowest Gross intake ratio(%) in Brunei Darussalam?
Offer a terse response. 8.87. What is the difference between the highest and the lowest Gross intake ratio(%) in Latvia?
Provide a short and direct response. 11.2. What is the difference between the highest and the lowest Gross intake ratio(%) in Tanzania?
Provide a short and direct response. 64.74. What is the difference between the highest and the lowest Gross intake ratio(%) of Uganda?
Keep it short and to the point. 40.43. 